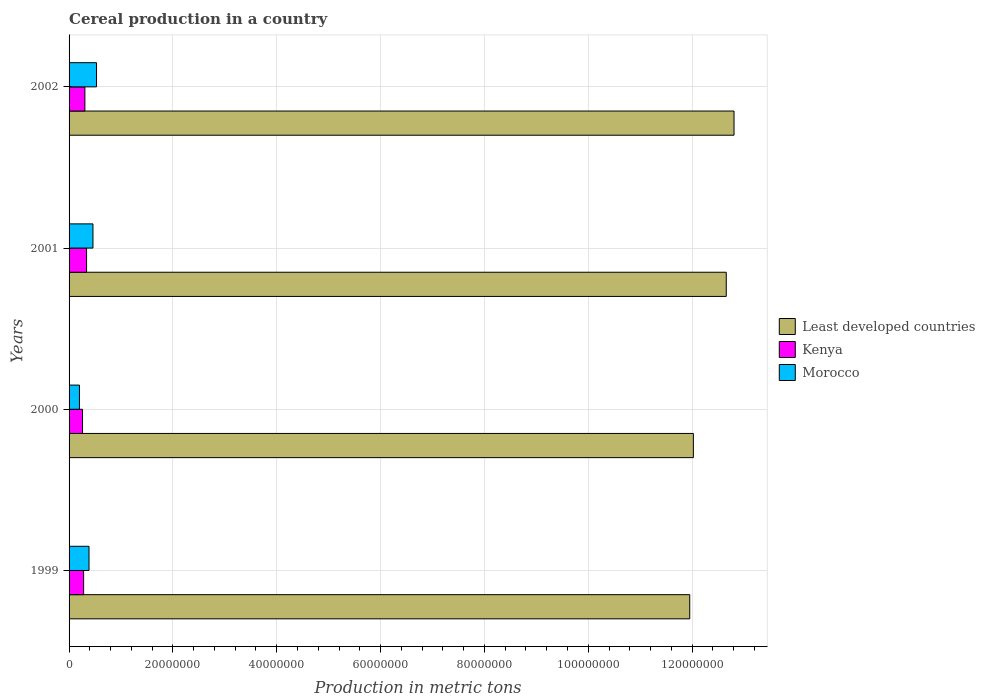How many different coloured bars are there?
Give a very brief answer. 3. How many groups of bars are there?
Your answer should be compact. 4. Are the number of bars per tick equal to the number of legend labels?
Your answer should be compact. Yes. What is the label of the 3rd group of bars from the top?
Give a very brief answer. 2000. What is the total cereal production in Least developed countries in 2002?
Make the answer very short. 1.28e+08. Across all years, what is the maximum total cereal production in Kenya?
Your response must be concise. 3.37e+06. Across all years, what is the minimum total cereal production in Kenya?
Ensure brevity in your answer.  2.59e+06. In which year was the total cereal production in Kenya maximum?
Make the answer very short. 2001. What is the total total cereal production in Morocco in the graph?
Provide a succinct answer. 1.57e+07. What is the difference between the total cereal production in Morocco in 2001 and that in 2002?
Offer a very short reply. -6.86e+05. What is the difference between the total cereal production in Least developed countries in 2000 and the total cereal production in Morocco in 2002?
Your answer should be compact. 1.15e+08. What is the average total cereal production in Least developed countries per year?
Ensure brevity in your answer.  1.24e+08. In the year 2002, what is the difference between the total cereal production in Least developed countries and total cereal production in Morocco?
Your answer should be very brief. 1.23e+08. What is the ratio of the total cereal production in Kenya in 1999 to that in 2001?
Offer a terse response. 0.83. Is the total cereal production in Least developed countries in 1999 less than that in 2000?
Your answer should be very brief. Yes. What is the difference between the highest and the second highest total cereal production in Kenya?
Provide a succinct answer. 3.25e+05. What is the difference between the highest and the lowest total cereal production in Least developed countries?
Ensure brevity in your answer.  8.53e+06. What does the 3rd bar from the top in 1999 represents?
Offer a terse response. Least developed countries. What does the 2nd bar from the bottom in 1999 represents?
Offer a terse response. Kenya. Is it the case that in every year, the sum of the total cereal production in Least developed countries and total cereal production in Morocco is greater than the total cereal production in Kenya?
Your response must be concise. Yes. How many bars are there?
Offer a very short reply. 12. Does the graph contain grids?
Provide a short and direct response. Yes. How are the legend labels stacked?
Ensure brevity in your answer.  Vertical. What is the title of the graph?
Your response must be concise. Cereal production in a country. What is the label or title of the X-axis?
Provide a short and direct response. Production in metric tons. What is the Production in metric tons of Least developed countries in 1999?
Give a very brief answer. 1.20e+08. What is the Production in metric tons in Kenya in 1999?
Offer a very short reply. 2.80e+06. What is the Production in metric tons in Morocco in 1999?
Your answer should be very brief. 3.84e+06. What is the Production in metric tons of Least developed countries in 2000?
Your answer should be compact. 1.20e+08. What is the Production in metric tons in Kenya in 2000?
Your response must be concise. 2.59e+06. What is the Production in metric tons of Morocco in 2000?
Offer a very short reply. 2.00e+06. What is the Production in metric tons in Least developed countries in 2001?
Give a very brief answer. 1.27e+08. What is the Production in metric tons in Kenya in 2001?
Your answer should be compact. 3.37e+06. What is the Production in metric tons in Morocco in 2001?
Your response must be concise. 4.60e+06. What is the Production in metric tons of Least developed countries in 2002?
Provide a succinct answer. 1.28e+08. What is the Production in metric tons of Kenya in 2002?
Make the answer very short. 3.05e+06. What is the Production in metric tons in Morocco in 2002?
Your answer should be compact. 5.29e+06. Across all years, what is the maximum Production in metric tons of Least developed countries?
Your answer should be very brief. 1.28e+08. Across all years, what is the maximum Production in metric tons of Kenya?
Your answer should be very brief. 3.37e+06. Across all years, what is the maximum Production in metric tons of Morocco?
Make the answer very short. 5.29e+06. Across all years, what is the minimum Production in metric tons of Least developed countries?
Keep it short and to the point. 1.20e+08. Across all years, what is the minimum Production in metric tons of Kenya?
Give a very brief answer. 2.59e+06. Across all years, what is the minimum Production in metric tons of Morocco?
Provide a succinct answer. 2.00e+06. What is the total Production in metric tons of Least developed countries in the graph?
Keep it short and to the point. 4.94e+08. What is the total Production in metric tons of Kenya in the graph?
Your response must be concise. 1.18e+07. What is the total Production in metric tons in Morocco in the graph?
Your response must be concise. 1.57e+07. What is the difference between the Production in metric tons in Least developed countries in 1999 and that in 2000?
Provide a succinct answer. -7.00e+05. What is the difference between the Production in metric tons in Kenya in 1999 and that in 2000?
Give a very brief answer. 2.11e+05. What is the difference between the Production in metric tons in Morocco in 1999 and that in 2000?
Your answer should be very brief. 1.85e+06. What is the difference between the Production in metric tons in Least developed countries in 1999 and that in 2001?
Your response must be concise. -7.03e+06. What is the difference between the Production in metric tons of Kenya in 1999 and that in 2001?
Keep it short and to the point. -5.68e+05. What is the difference between the Production in metric tons in Morocco in 1999 and that in 2001?
Give a very brief answer. -7.60e+05. What is the difference between the Production in metric tons in Least developed countries in 1999 and that in 2002?
Offer a terse response. -8.53e+06. What is the difference between the Production in metric tons of Kenya in 1999 and that in 2002?
Make the answer very short. -2.43e+05. What is the difference between the Production in metric tons of Morocco in 1999 and that in 2002?
Give a very brief answer. -1.45e+06. What is the difference between the Production in metric tons in Least developed countries in 2000 and that in 2001?
Offer a very short reply. -6.33e+06. What is the difference between the Production in metric tons in Kenya in 2000 and that in 2001?
Your answer should be very brief. -7.79e+05. What is the difference between the Production in metric tons of Morocco in 2000 and that in 2001?
Your answer should be compact. -2.61e+06. What is the difference between the Production in metric tons of Least developed countries in 2000 and that in 2002?
Your response must be concise. -7.83e+06. What is the difference between the Production in metric tons of Kenya in 2000 and that in 2002?
Provide a succinct answer. -4.54e+05. What is the difference between the Production in metric tons of Morocco in 2000 and that in 2002?
Make the answer very short. -3.29e+06. What is the difference between the Production in metric tons of Least developed countries in 2001 and that in 2002?
Make the answer very short. -1.49e+06. What is the difference between the Production in metric tons of Kenya in 2001 and that in 2002?
Ensure brevity in your answer.  3.25e+05. What is the difference between the Production in metric tons in Morocco in 2001 and that in 2002?
Provide a short and direct response. -6.86e+05. What is the difference between the Production in metric tons of Least developed countries in 1999 and the Production in metric tons of Kenya in 2000?
Provide a short and direct response. 1.17e+08. What is the difference between the Production in metric tons of Least developed countries in 1999 and the Production in metric tons of Morocco in 2000?
Ensure brevity in your answer.  1.18e+08. What is the difference between the Production in metric tons in Kenya in 1999 and the Production in metric tons in Morocco in 2000?
Your response must be concise. 8.06e+05. What is the difference between the Production in metric tons of Least developed countries in 1999 and the Production in metric tons of Kenya in 2001?
Ensure brevity in your answer.  1.16e+08. What is the difference between the Production in metric tons in Least developed countries in 1999 and the Production in metric tons in Morocco in 2001?
Give a very brief answer. 1.15e+08. What is the difference between the Production in metric tons in Kenya in 1999 and the Production in metric tons in Morocco in 2001?
Ensure brevity in your answer.  -1.80e+06. What is the difference between the Production in metric tons of Least developed countries in 1999 and the Production in metric tons of Kenya in 2002?
Keep it short and to the point. 1.16e+08. What is the difference between the Production in metric tons of Least developed countries in 1999 and the Production in metric tons of Morocco in 2002?
Your answer should be compact. 1.14e+08. What is the difference between the Production in metric tons of Kenya in 1999 and the Production in metric tons of Morocco in 2002?
Give a very brief answer. -2.49e+06. What is the difference between the Production in metric tons of Least developed countries in 2000 and the Production in metric tons of Kenya in 2001?
Your answer should be compact. 1.17e+08. What is the difference between the Production in metric tons of Least developed countries in 2000 and the Production in metric tons of Morocco in 2001?
Ensure brevity in your answer.  1.16e+08. What is the difference between the Production in metric tons in Kenya in 2000 and the Production in metric tons in Morocco in 2001?
Ensure brevity in your answer.  -2.01e+06. What is the difference between the Production in metric tons in Least developed countries in 2000 and the Production in metric tons in Kenya in 2002?
Make the answer very short. 1.17e+08. What is the difference between the Production in metric tons of Least developed countries in 2000 and the Production in metric tons of Morocco in 2002?
Your answer should be very brief. 1.15e+08. What is the difference between the Production in metric tons in Kenya in 2000 and the Production in metric tons in Morocco in 2002?
Your answer should be very brief. -2.70e+06. What is the difference between the Production in metric tons of Least developed countries in 2001 and the Production in metric tons of Kenya in 2002?
Make the answer very short. 1.24e+08. What is the difference between the Production in metric tons in Least developed countries in 2001 and the Production in metric tons in Morocco in 2002?
Keep it short and to the point. 1.21e+08. What is the difference between the Production in metric tons in Kenya in 2001 and the Production in metric tons in Morocco in 2002?
Ensure brevity in your answer.  -1.92e+06. What is the average Production in metric tons in Least developed countries per year?
Provide a short and direct response. 1.24e+08. What is the average Production in metric tons of Kenya per year?
Provide a short and direct response. 2.95e+06. What is the average Production in metric tons of Morocco per year?
Your response must be concise. 3.93e+06. In the year 1999, what is the difference between the Production in metric tons in Least developed countries and Production in metric tons in Kenya?
Give a very brief answer. 1.17e+08. In the year 1999, what is the difference between the Production in metric tons of Least developed countries and Production in metric tons of Morocco?
Give a very brief answer. 1.16e+08. In the year 1999, what is the difference between the Production in metric tons in Kenya and Production in metric tons in Morocco?
Your answer should be very brief. -1.04e+06. In the year 2000, what is the difference between the Production in metric tons in Least developed countries and Production in metric tons in Kenya?
Ensure brevity in your answer.  1.18e+08. In the year 2000, what is the difference between the Production in metric tons of Least developed countries and Production in metric tons of Morocco?
Provide a short and direct response. 1.18e+08. In the year 2000, what is the difference between the Production in metric tons of Kenya and Production in metric tons of Morocco?
Ensure brevity in your answer.  5.95e+05. In the year 2001, what is the difference between the Production in metric tons in Least developed countries and Production in metric tons in Kenya?
Provide a short and direct response. 1.23e+08. In the year 2001, what is the difference between the Production in metric tons in Least developed countries and Production in metric tons in Morocco?
Keep it short and to the point. 1.22e+08. In the year 2001, what is the difference between the Production in metric tons of Kenya and Production in metric tons of Morocco?
Keep it short and to the point. -1.23e+06. In the year 2002, what is the difference between the Production in metric tons in Least developed countries and Production in metric tons in Kenya?
Keep it short and to the point. 1.25e+08. In the year 2002, what is the difference between the Production in metric tons in Least developed countries and Production in metric tons in Morocco?
Give a very brief answer. 1.23e+08. In the year 2002, what is the difference between the Production in metric tons in Kenya and Production in metric tons in Morocco?
Provide a succinct answer. -2.24e+06. What is the ratio of the Production in metric tons of Kenya in 1999 to that in 2000?
Your answer should be compact. 1.08. What is the ratio of the Production in metric tons of Morocco in 1999 to that in 2000?
Ensure brevity in your answer.  1.93. What is the ratio of the Production in metric tons in Kenya in 1999 to that in 2001?
Offer a terse response. 0.83. What is the ratio of the Production in metric tons in Morocco in 1999 to that in 2001?
Your answer should be very brief. 0.83. What is the ratio of the Production in metric tons of Least developed countries in 1999 to that in 2002?
Your response must be concise. 0.93. What is the ratio of the Production in metric tons in Kenya in 1999 to that in 2002?
Provide a short and direct response. 0.92. What is the ratio of the Production in metric tons in Morocco in 1999 to that in 2002?
Ensure brevity in your answer.  0.73. What is the ratio of the Production in metric tons of Least developed countries in 2000 to that in 2001?
Your answer should be compact. 0.95. What is the ratio of the Production in metric tons of Kenya in 2000 to that in 2001?
Ensure brevity in your answer.  0.77. What is the ratio of the Production in metric tons of Morocco in 2000 to that in 2001?
Give a very brief answer. 0.43. What is the ratio of the Production in metric tons of Least developed countries in 2000 to that in 2002?
Keep it short and to the point. 0.94. What is the ratio of the Production in metric tons of Kenya in 2000 to that in 2002?
Keep it short and to the point. 0.85. What is the ratio of the Production in metric tons in Morocco in 2000 to that in 2002?
Provide a short and direct response. 0.38. What is the ratio of the Production in metric tons in Least developed countries in 2001 to that in 2002?
Make the answer very short. 0.99. What is the ratio of the Production in metric tons in Kenya in 2001 to that in 2002?
Ensure brevity in your answer.  1.11. What is the ratio of the Production in metric tons of Morocco in 2001 to that in 2002?
Your answer should be compact. 0.87. What is the difference between the highest and the second highest Production in metric tons in Least developed countries?
Offer a terse response. 1.49e+06. What is the difference between the highest and the second highest Production in metric tons of Kenya?
Provide a succinct answer. 3.25e+05. What is the difference between the highest and the second highest Production in metric tons of Morocco?
Keep it short and to the point. 6.86e+05. What is the difference between the highest and the lowest Production in metric tons in Least developed countries?
Your answer should be very brief. 8.53e+06. What is the difference between the highest and the lowest Production in metric tons of Kenya?
Keep it short and to the point. 7.79e+05. What is the difference between the highest and the lowest Production in metric tons of Morocco?
Ensure brevity in your answer.  3.29e+06. 